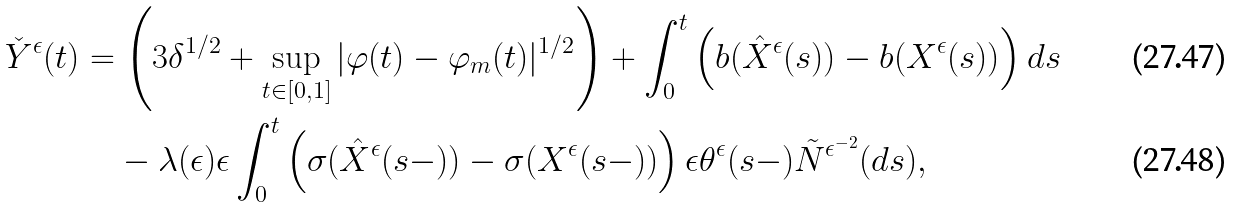<formula> <loc_0><loc_0><loc_500><loc_500>\check { Y } ^ { \epsilon } ( t ) & = \left ( 3 \delta ^ { 1 / 2 } + \sup _ { t \in [ 0 , 1 ] } | \varphi ( t ) - \varphi _ { m } ( t ) | ^ { 1 / 2 } \right ) + \int ^ { t } _ { 0 } \left ( b ( \hat { X } ^ { \epsilon } ( s ) ) - b ( X ^ { \epsilon } ( s ) ) \right ) d s \\ & \quad - \lambda ( \epsilon ) \epsilon \int ^ { t } _ { 0 } \left ( \sigma ( \hat { X } ^ { \epsilon } ( s - ) ) - \sigma ( X ^ { \epsilon } ( s - ) ) \right ) \epsilon \theta ^ { \epsilon } ( s - ) \tilde { N } ^ { \epsilon ^ { - 2 } } ( d s ) ,</formula> 